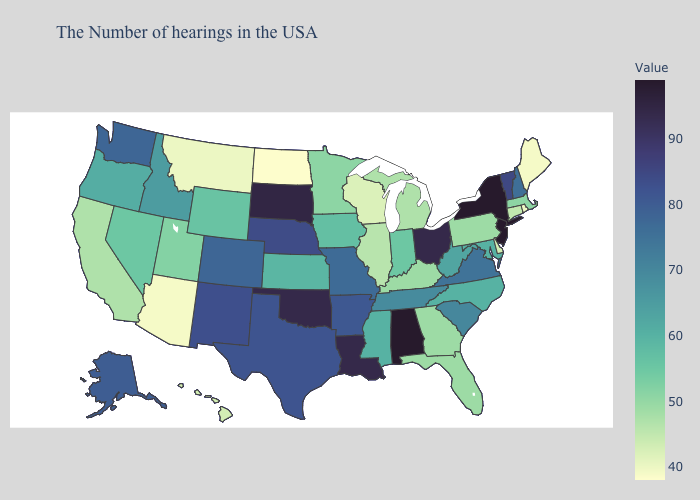Among the states that border South Carolina , which have the lowest value?
Short answer required. Georgia. Does California have the lowest value in the USA?
Concise answer only. No. Among the states that border Missouri , does Oklahoma have the highest value?
Keep it brief. Yes. 